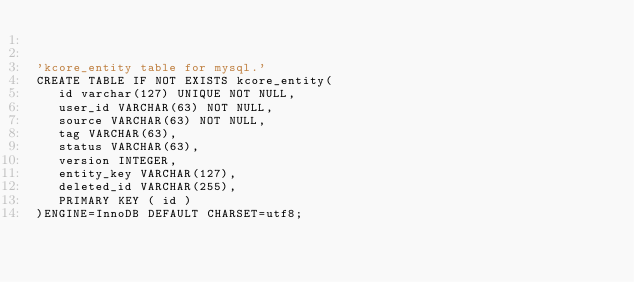<code> <loc_0><loc_0><loc_500><loc_500><_SQL_>

'kcore_entity table for mysql.'
CREATE TABLE IF NOT EXISTS kcore_entity(
   id varchar(127) UNIQUE NOT NULL,
   user_id VARCHAR(63) NOT NULL,
   source VARCHAR(63) NOT NULL,
   tag VARCHAR(63),
   status VARCHAR(63),
   version INTEGER,
   entity_key VARCHAR(127),
   deleted_id VARCHAR(255),
   PRIMARY KEY ( id )
)ENGINE=InnoDB DEFAULT CHARSET=utf8;</code> 